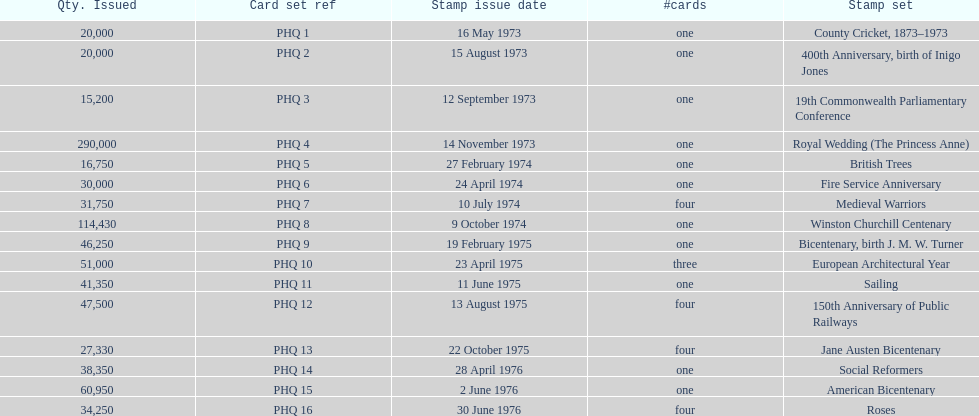How many stamp sets had at least 50,000 issued? 4. 